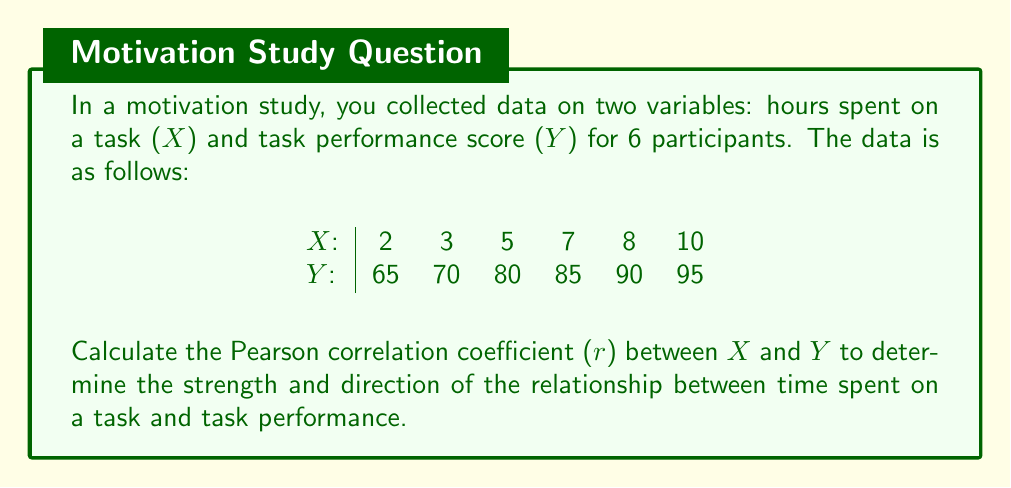Could you help me with this problem? To calculate the Pearson correlation coefficient (r), we'll follow these steps:

1. Calculate the means of X and Y:
   $\bar{X} = \frac{\sum X}{n} = \frac{2 + 3 + 5 + 7 + 8 + 10}{6} = \frac{35}{6} = 5.83$
   $\bar{Y} = \frac{\sum Y}{n} = \frac{65 + 70 + 80 + 85 + 90 + 95}{6} = \frac{485}{6} = 80.83$

2. Calculate the deviations from the mean for X and Y:
   X deviations: -3.83, -2.83, -0.83, 1.17, 2.17, 4.17
   Y deviations: -15.83, -10.83, -0.83, 4.17, 9.17, 14.17

3. Calculate the products of the deviations:
   60.63, 30.65, 0.69, 4.88, 19.90, 59.09

4. Calculate the sums needed for the correlation formula:
   $\sum (X - \bar{X})(Y - \bar{Y}) = 175.84$
   $\sum (X - \bar{X})^2 = 58.83$
   $\sum (Y - \bar{Y})^2 = 758.83$

5. Apply the Pearson correlation coefficient formula:

   $$r = \frac{\sum (X - \bar{X})(Y - \bar{Y})}{\sqrt{\sum (X - \bar{X})^2 \sum (Y - \bar{Y})^2}}$$

   $$r = \frac{175.84}{\sqrt{58.83 \times 758.83}}$$

   $$r = \frac{175.84}{\sqrt{44,647.29}}$$

   $$r = \frac{175.84}{211.30}$$

   $$r \approx 0.9921$$
Answer: $r \approx 0.9921$ 